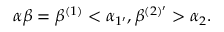<formula> <loc_0><loc_0><loc_500><loc_500>\alpha \beta = \beta ^ { ( 1 ) } < \alpha _ { 1 ^ { \prime } } , \beta ^ { ( 2 ) ^ { \prime } } > \alpha _ { 2 } .</formula> 